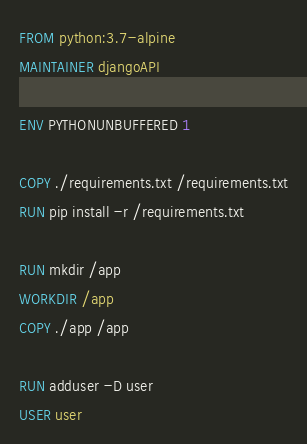<code> <loc_0><loc_0><loc_500><loc_500><_Dockerfile_>FROM python:3.7-alpine
MAINTAINER djangoAPI

ENV PYTHONUNBUFFERED 1

COPY ./requirements.txt /requirements.txt
RUN pip install -r /requirements.txt

RUN mkdir /app
WORKDIR /app
COPY ./app /app

RUN adduser -D user
USER user
</code> 